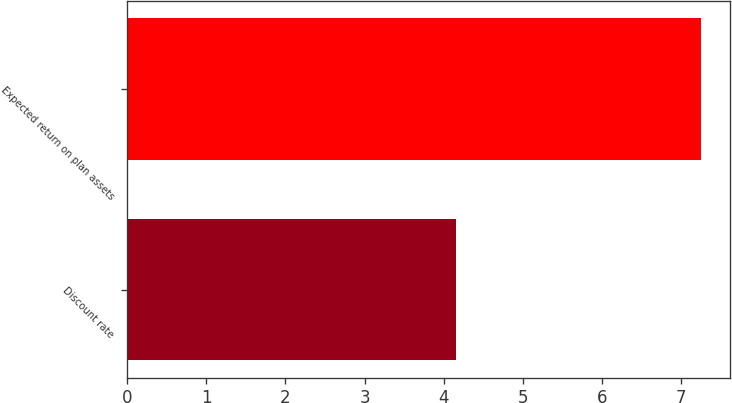Convert chart to OTSL. <chart><loc_0><loc_0><loc_500><loc_500><bar_chart><fcel>Discount rate<fcel>Expected return on plan assets<nl><fcel>4.15<fcel>7.25<nl></chart> 